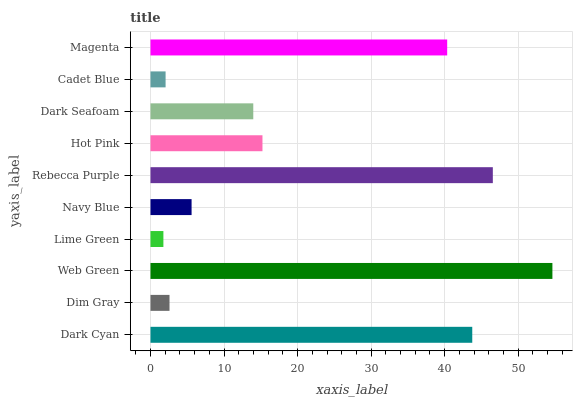Is Lime Green the minimum?
Answer yes or no. Yes. Is Web Green the maximum?
Answer yes or no. Yes. Is Dim Gray the minimum?
Answer yes or no. No. Is Dim Gray the maximum?
Answer yes or no. No. Is Dark Cyan greater than Dim Gray?
Answer yes or no. Yes. Is Dim Gray less than Dark Cyan?
Answer yes or no. Yes. Is Dim Gray greater than Dark Cyan?
Answer yes or no. No. Is Dark Cyan less than Dim Gray?
Answer yes or no. No. Is Hot Pink the high median?
Answer yes or no. Yes. Is Dark Seafoam the low median?
Answer yes or no. Yes. Is Lime Green the high median?
Answer yes or no. No. Is Lime Green the low median?
Answer yes or no. No. 